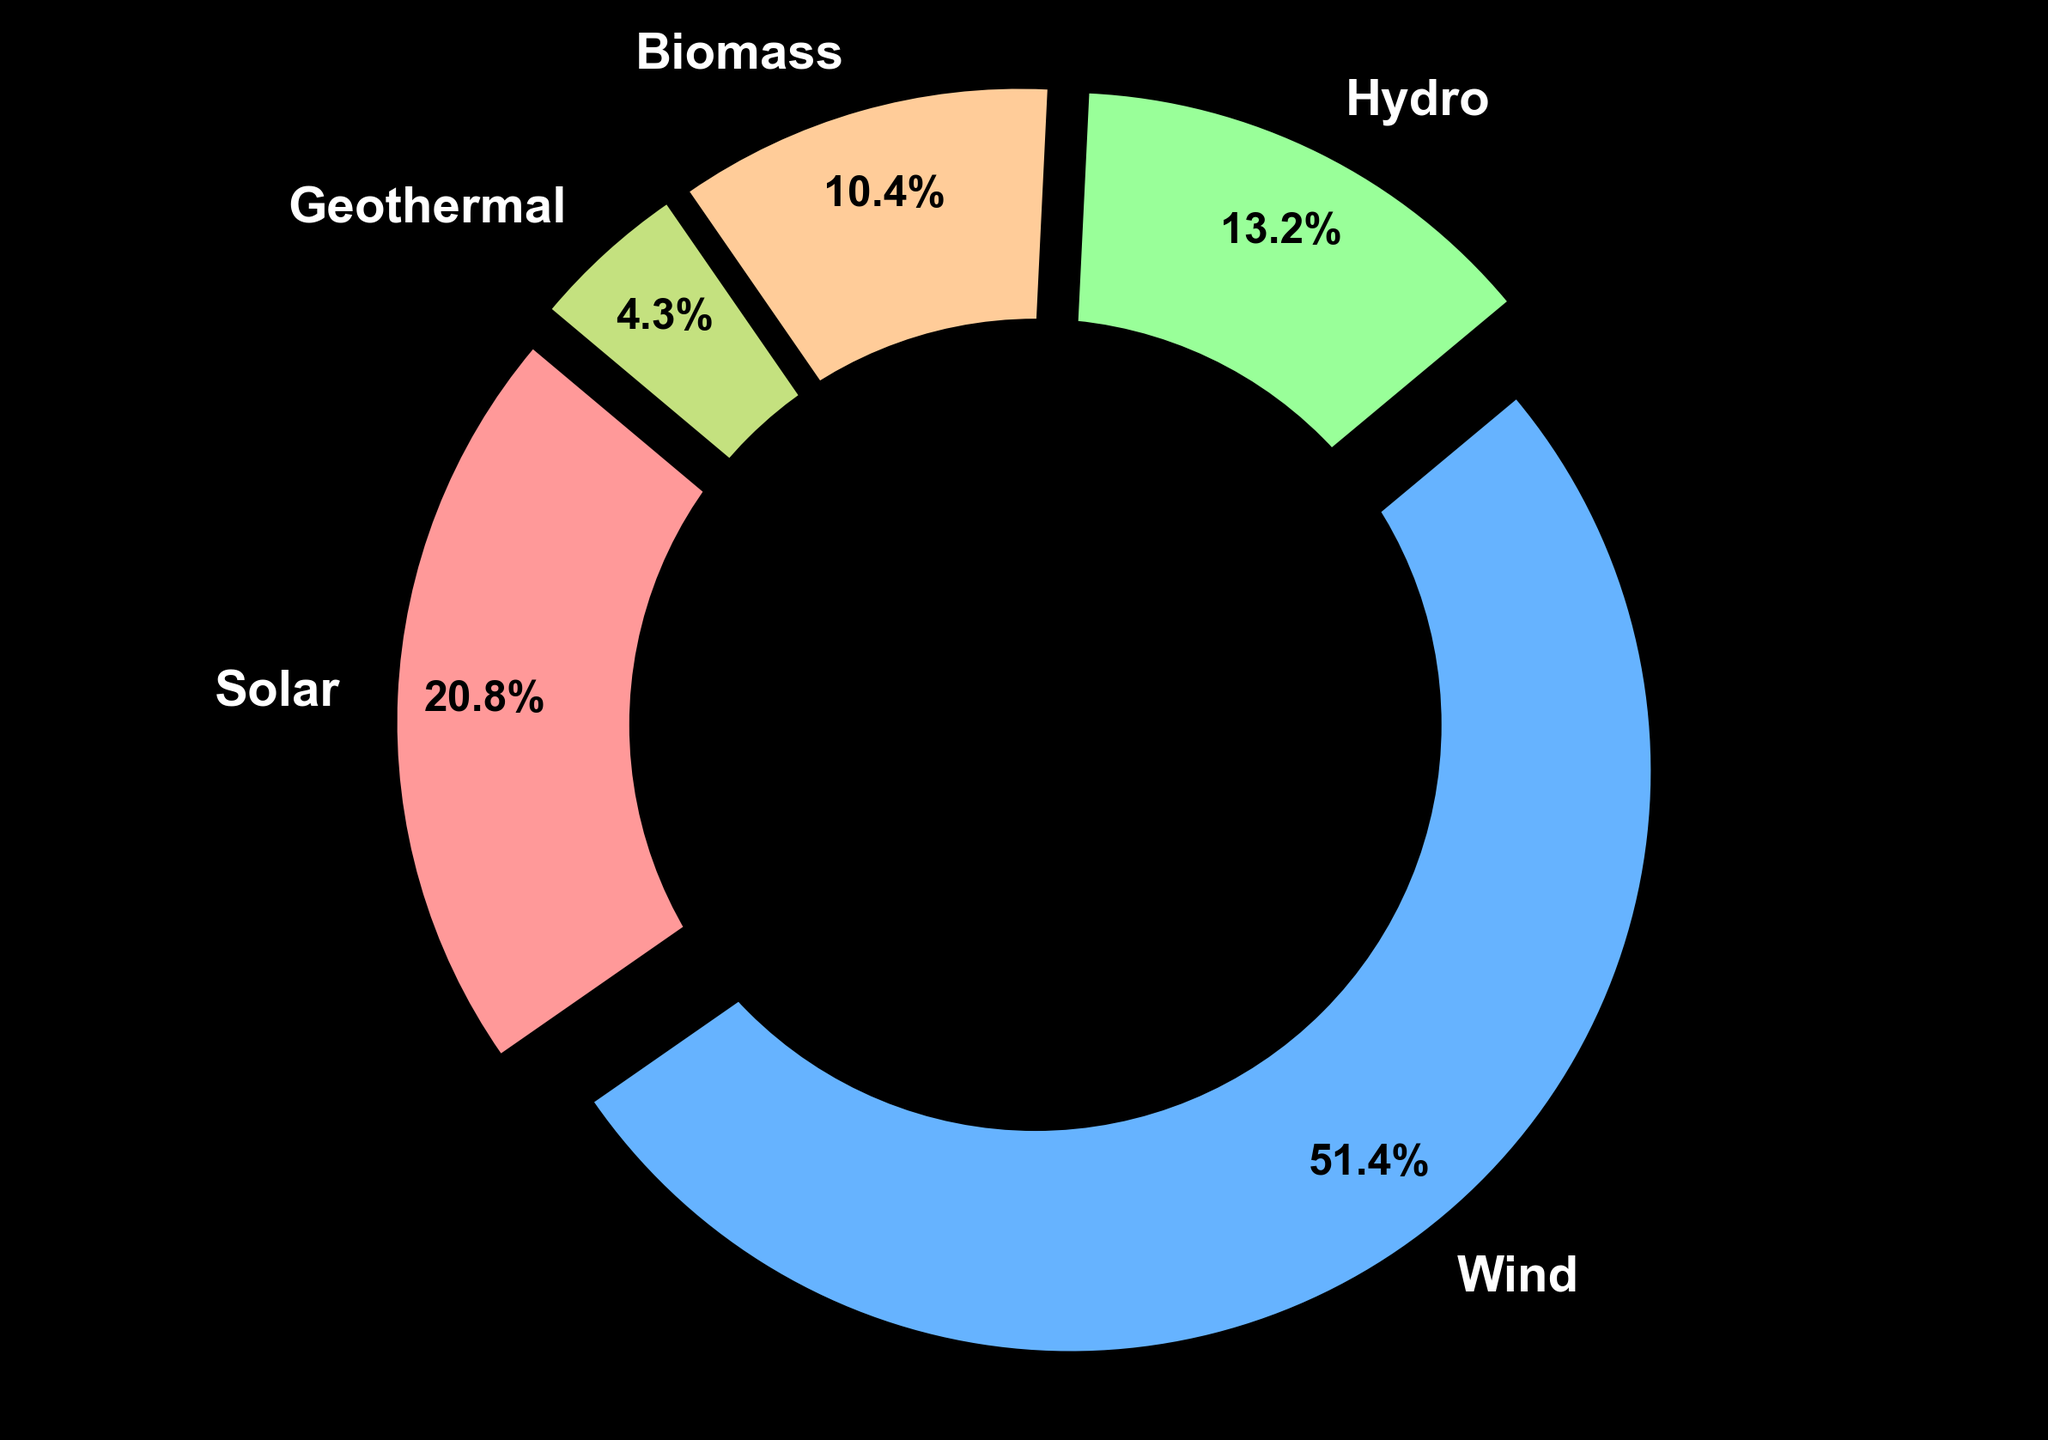What is the largest renewable energy source in the US energy market based on the chart? The largest section of the pie chart, which represents Wind, has the highest percentage of 27.7%.
Answer: Wind Which renewable energy source has the smallest share in the US energy market? The smallest section of the pie chart, which represents Geothermal, has the lowest percentage of 2.3%.
Answer: Geothermal How much more energy does Wind contribute compared to Hydro? Wind contributes 27.7%, and Hydro contributes 7.1%. The difference is 27.7% - 7.1% = 20.6%.
Answer: 20.6% If we combine the contributions of Solar and Hydro, what percentage of the US energy market do they represent together? Solar contributes 11.2% and Hydro contributes 7.1%. Combining them, the total is 11.2% + 7.1% = 18.3%.
Answer: 18.3% Are there more energy sources in the 'Others' category or contributions from Biomass? The 'Others' category includes Biomass and Geothermal. Biomass is 5.6%, and Geothermal is 2.3%. Together, they represent 5.6% + 2.3% = 7.9%.
Answer: Others Which energy source is slightly over a quarter of the total renewable energy in the US market? Wind represents 27.7%, which is slightly over 25%.
Answer: Wind How does the share of Solar energy compare to the share of Biomass energy in the US energy market? Solar contributes 11.2%, which is more than Biomass at 5.6%.
Answer: Solar > Biomass What percentage of the renewable energy market is not covered by Wind, Solar, and Hydro combined? Adding Wind (27.7%), Solar (11.2%), and Hydro (7.1%) together gives 27.7% + 11.2% + 7.1% = 46%. 100% - 46% = 54%.
Answer: 54% 